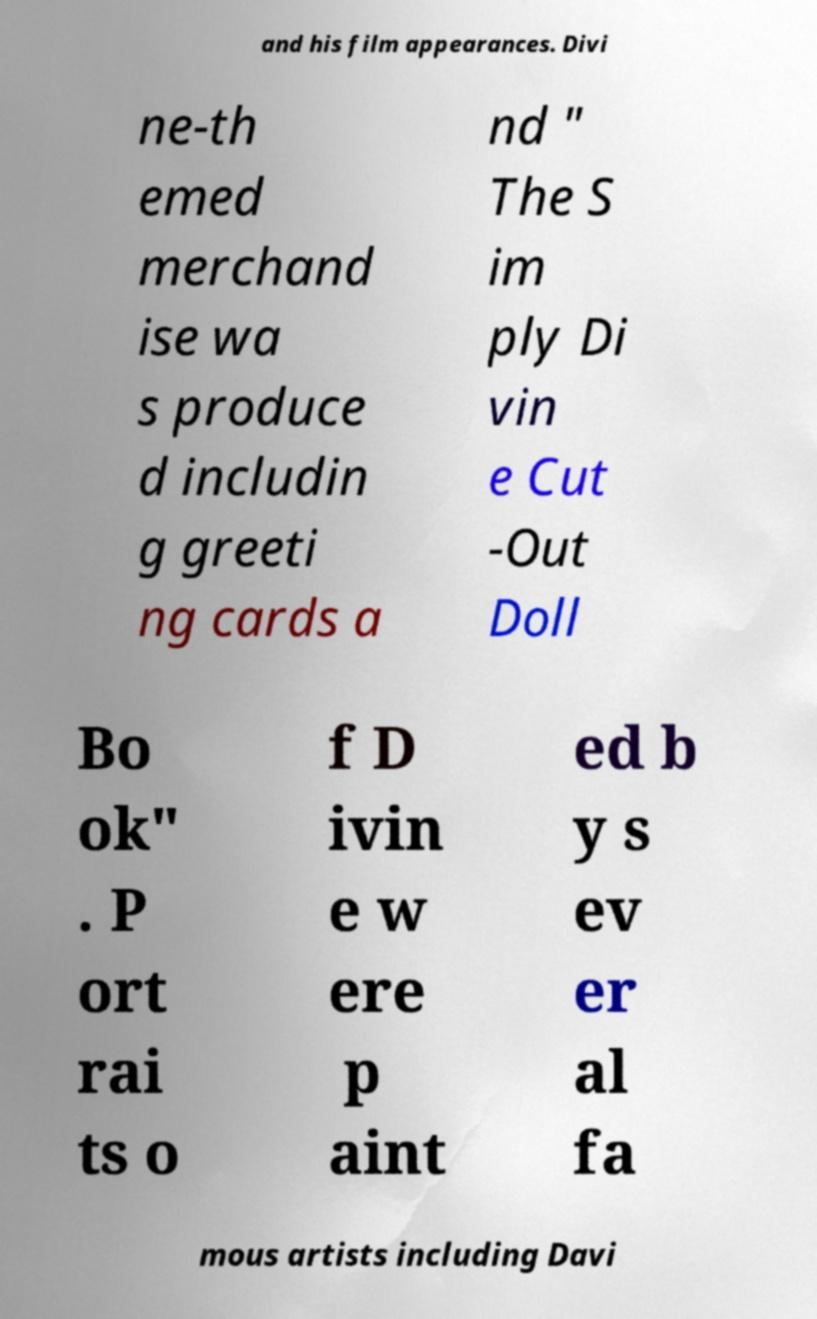Please read and relay the text visible in this image. What does it say? and his film appearances. Divi ne-th emed merchand ise wa s produce d includin g greeti ng cards a nd " The S im ply Di vin e Cut -Out Doll Bo ok" . P ort rai ts o f D ivin e w ere p aint ed b y s ev er al fa mous artists including Davi 